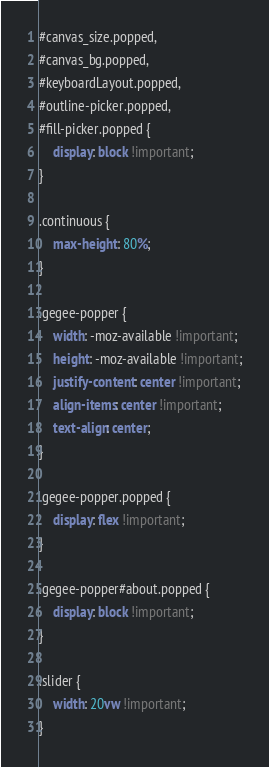<code> <loc_0><loc_0><loc_500><loc_500><_CSS_>#canvas_size.popped,
#canvas_bg.popped,
#keyboardLayout.popped,
#outline-picker.popped,
#fill-picker.popped {
    display: block !important;
}

.continuous {
    max-height: 80%;
}

.gegee-popper {
    width: -moz-available !important;
    height: -moz-available !important;
    justify-content: center !important;
    align-items: center !important;
    text-align: center;
}

.gegee-popper.popped {
    display: flex !important;
}

.gegee-popper#about.popped {
    display: block !important;
}

.slider {
    width: 20vw !important;
}</code> 